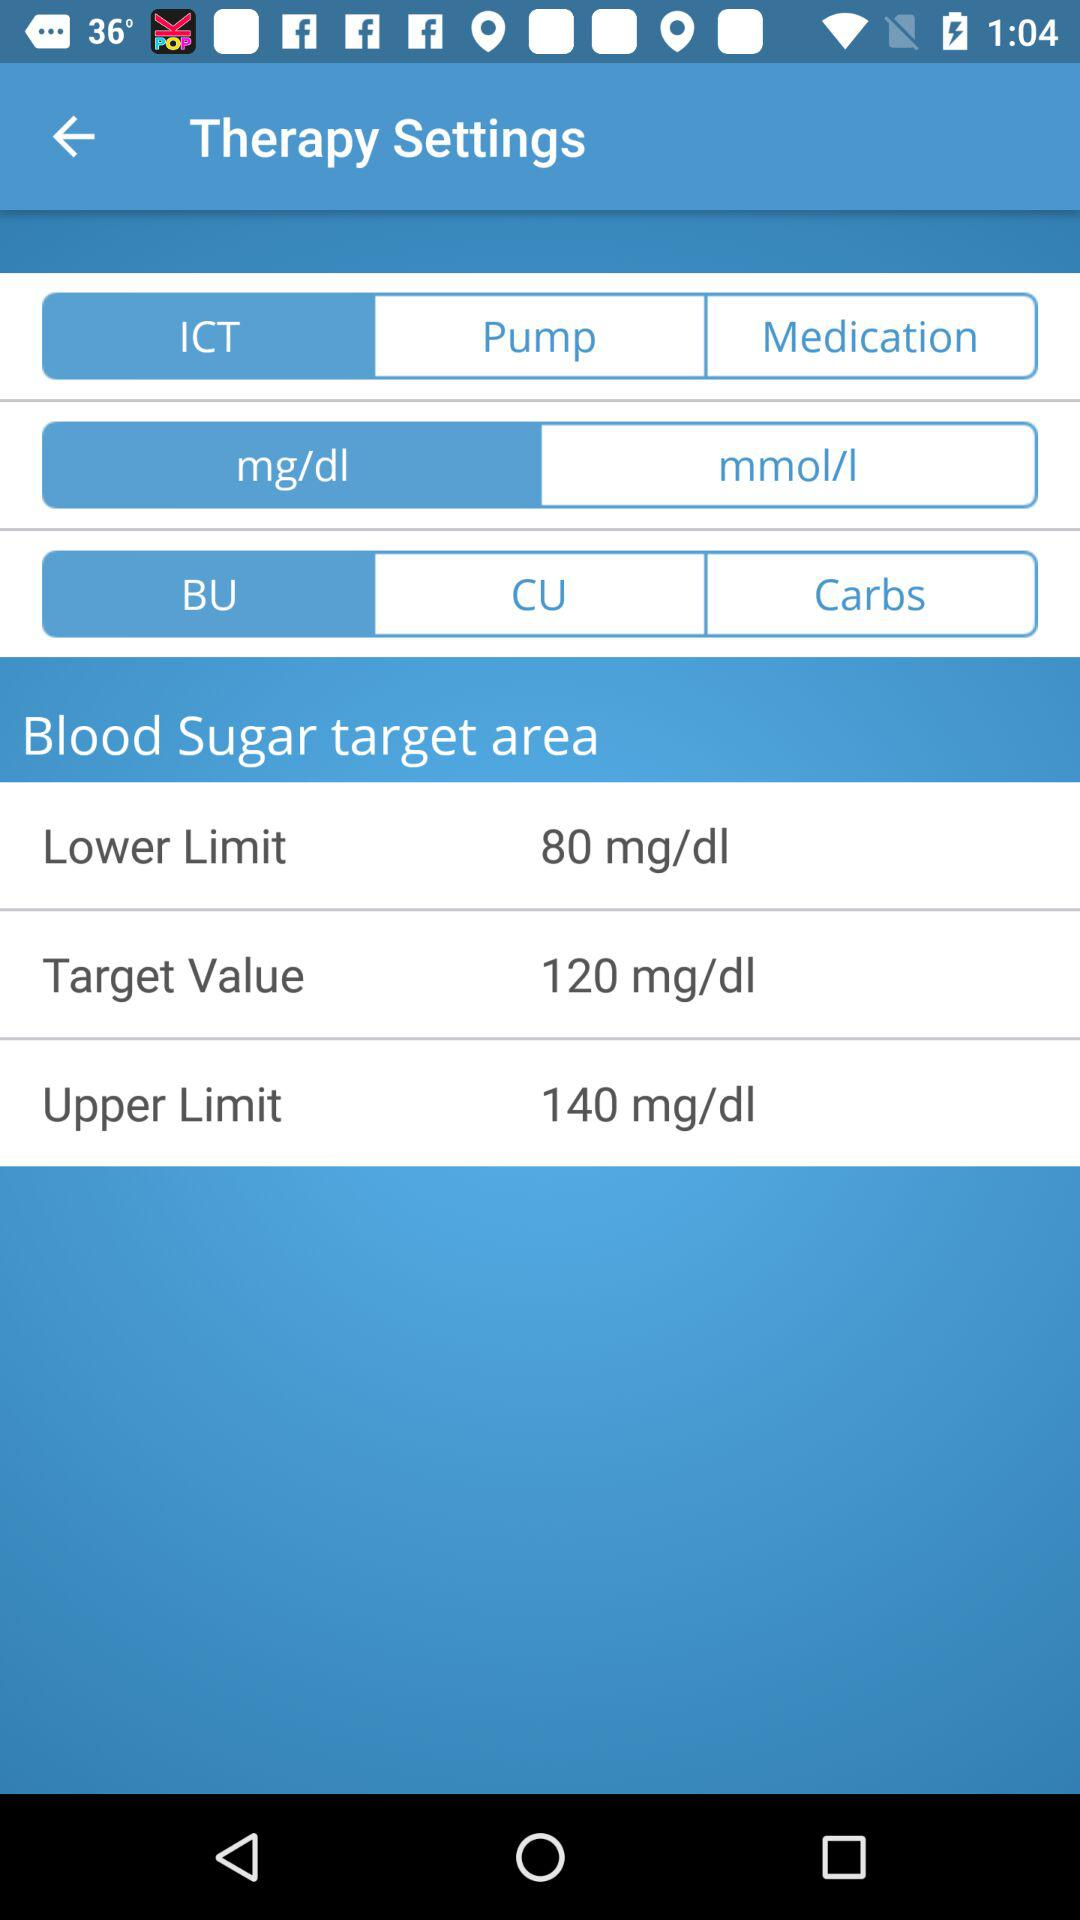What is the difference between the lower limit and the target value?
Answer the question using a single word or phrase. 40 mg/dl 